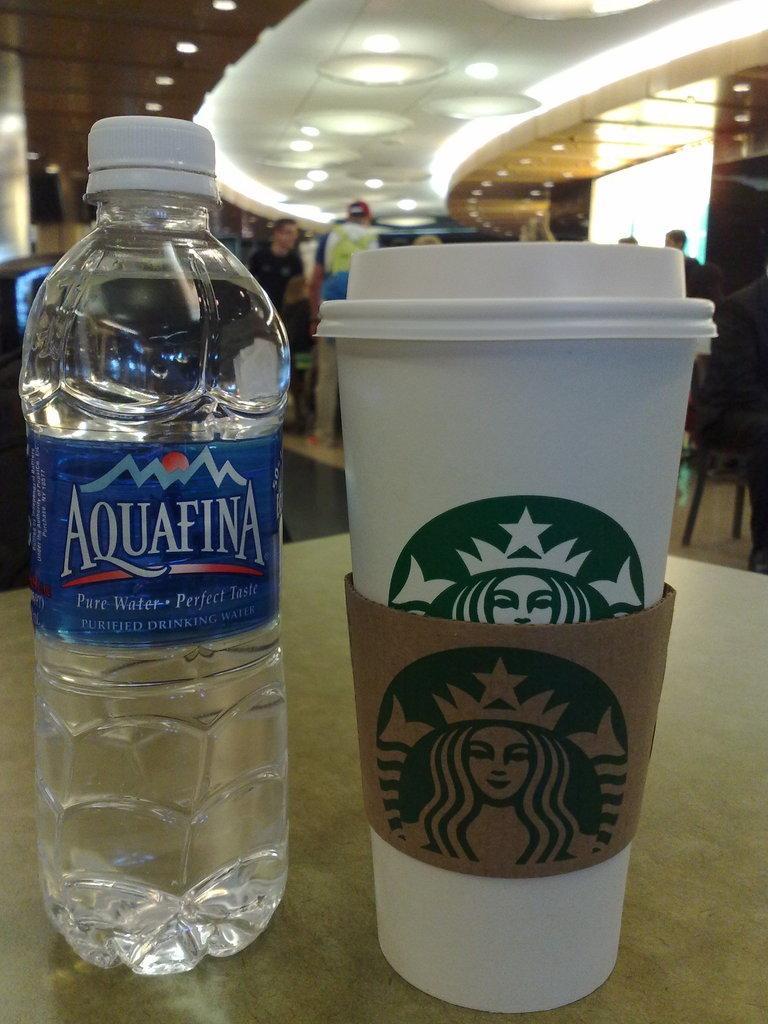In one or two sentences, can you explain what this image depicts? on the table there is a bottle and a cup. on the bottle aquafina is written. 